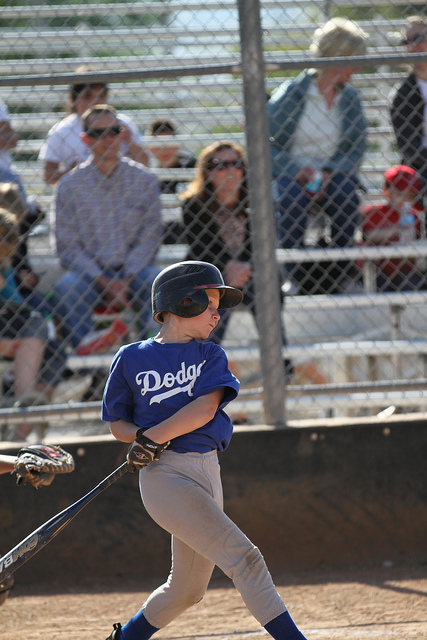Please extract the text content from this image. Dodar 